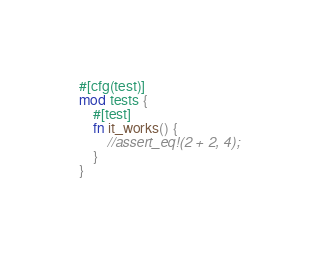<code> <loc_0><loc_0><loc_500><loc_500><_Rust_>#[cfg(test)]
mod tests {
    #[test]
    fn it_works() {
        //assert_eq!(2 + 2, 4);
    }
}
</code> 